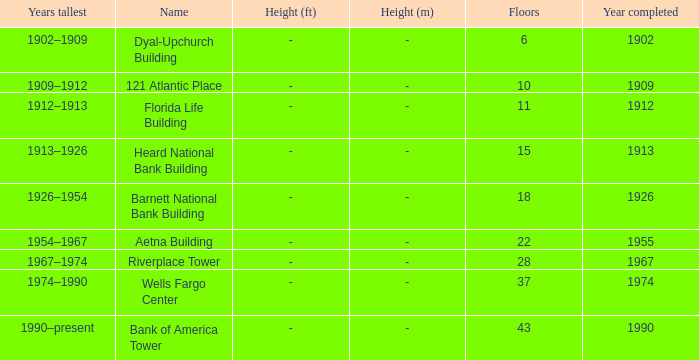What year was the building completed that has 10 floors? 1909.0. Help me parse the entirety of this table. {'header': ['Years tallest', 'Name', 'Height (ft)', 'Height (m)', 'Floors', 'Year completed'], 'rows': [['1902–1909', 'Dyal-Upchurch Building', '-', '-', '6', '1902'], ['1909–1912', '121 Atlantic Place', '-', '-', '10', '1909'], ['1912–1913', 'Florida Life Building', '-', '-', '11', '1912'], ['1913–1926', 'Heard National Bank Building', '-', '-', '15', '1913'], ['1926–1954', 'Barnett National Bank Building', '-', '-', '18', '1926'], ['1954–1967', 'Aetna Building', '-', '-', '22', '1955'], ['1967–1974', 'Riverplace Tower', '-', '-', '28', '1967'], ['1974–1990', 'Wells Fargo Center', '-', '-', '37', '1974'], ['1990–present', 'Bank of America Tower', '-', '-', '43', '1990']]} 